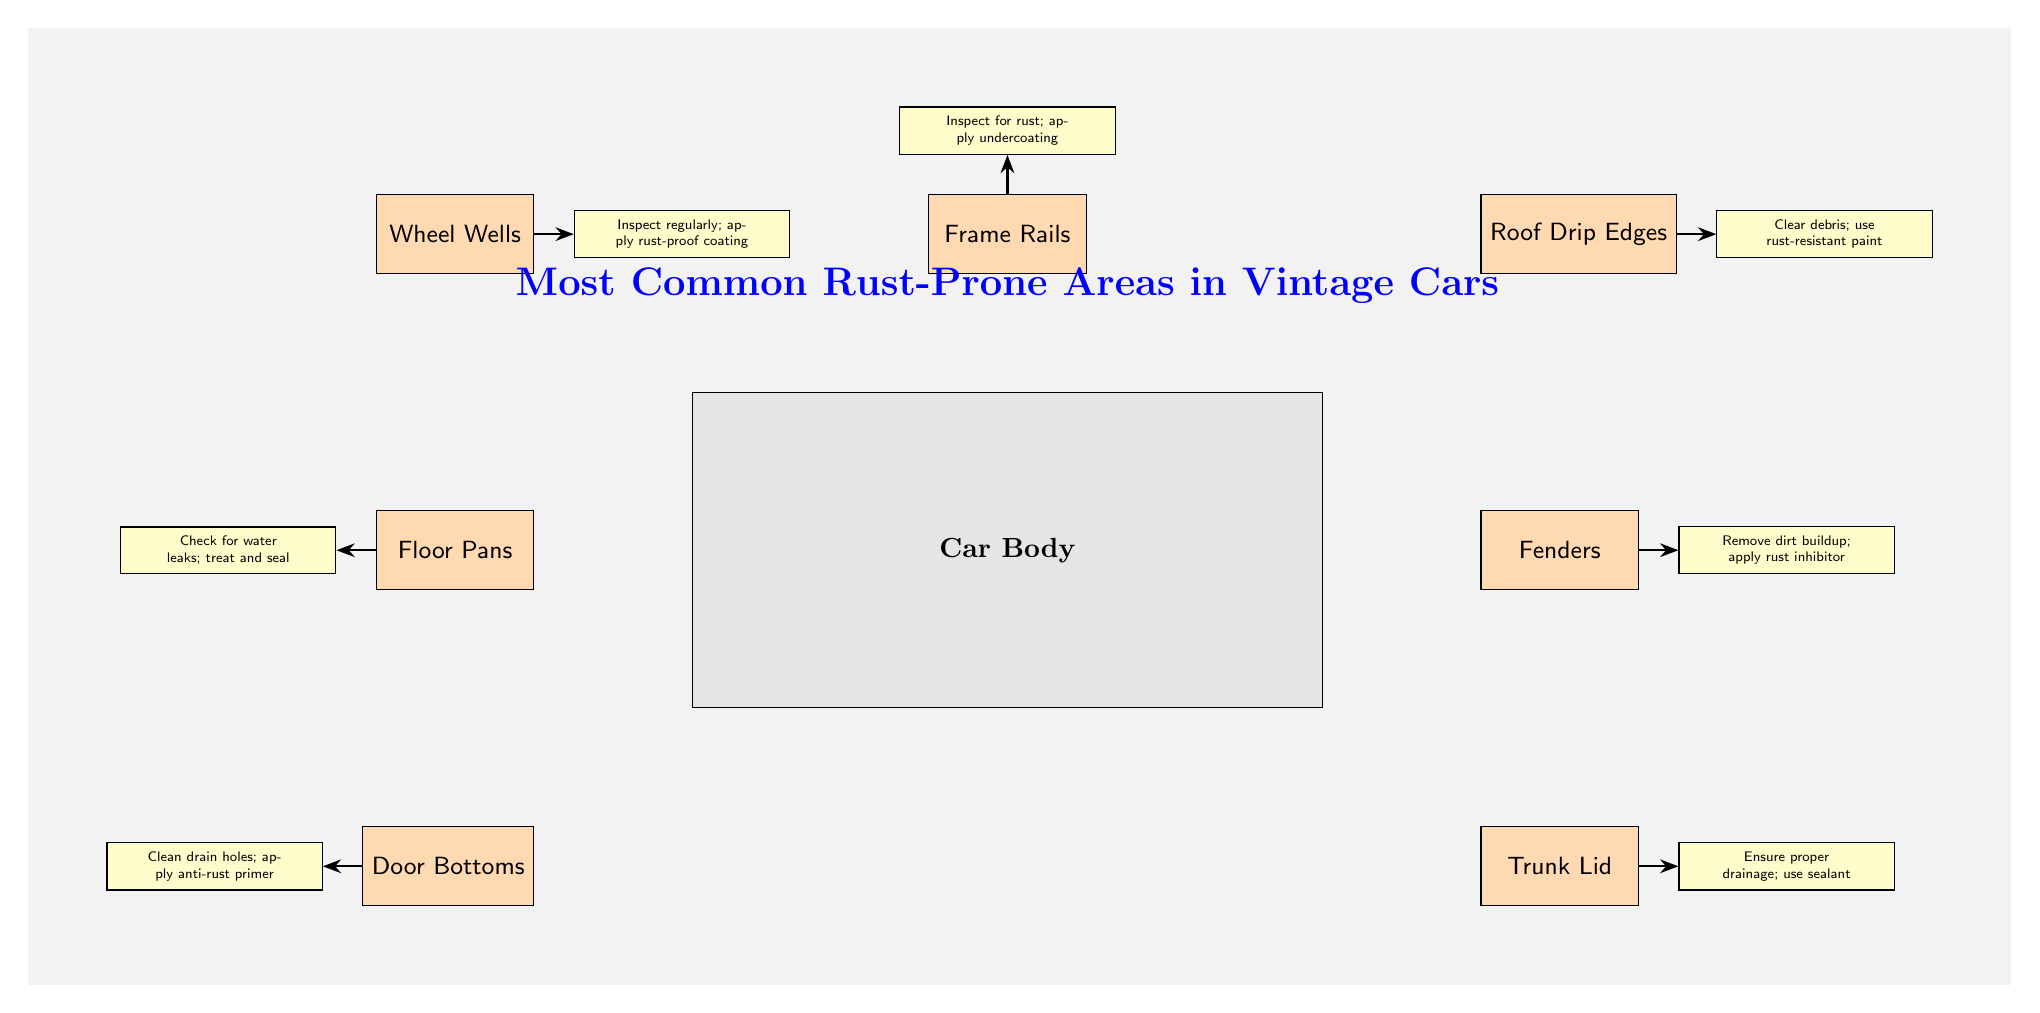What are the highlighted areas in the diagram? The diagram shows seven specific areas of the car body that are prone to rust, including Wheel Wells, Floor Pans, Door Bottoms, Trunk Lid, Fenders, Roof Drip Edges, and Frame Rails.
Answer: Wheel Wells, Floor Pans, Door Bottoms, Trunk Lid, Fenders, Roof Drip Edges, Frame Rails How many rust-prone areas are indicated in the diagram? The diagram highlights a total of seven areas that are common for rust, counting each area listed separately.
Answer: 7 Which area requires the application of a rust-proof coating? The diagram notes that the Wheel Wells need regular inspection and the application of rust-proof coating as a preventive measure.
Answer: Wheel Wells What is recommended for maintaining the Frame Rails? According to the diagram, it is recommended to inspect the Frame Rails for rust and apply undercoating to protect them effectively.
Answer: Inspect for rust; apply undercoating Which area mentions ensuring proper drainage? The Trunk Lid area in the diagram highlights the importance of ensuring proper drainage and suggests using a sealant for effective maintenance.
Answer: Trunk Lid What preventive action is suggested for the Door Bottoms? The diagram suggests cleaning drain holes and applying anti-rust primer to maintain the Door Bottoms effectively.
Answer: Clean drain holes; apply anti-rust primer What does each note connected to the rust-prone areas represent? Each note in the diagram provides specific maintenance tips or preventive actions that correlate with the highlighted rust-prone areas, aiming to reduce rust issues.
Answer: Maintenance tips Which area is positioned above the car body in the diagram? The diagram shows the Roof Drip Edges area positioned above the Car Body, illustrating its location relative to other highlighted areas.
Answer: Roof Drip Edges 